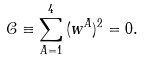<formula> <loc_0><loc_0><loc_500><loc_500>\mathcal { C } \equiv \sum _ { A = 1 } ^ { 4 } \, ( w ^ { A } ) ^ { 2 } = 0 .</formula> 